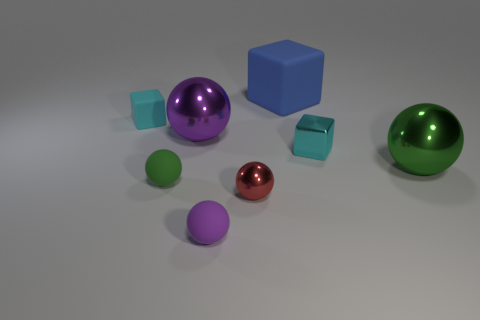How big is the cyan metallic object?
Keep it short and to the point. Small. How many cylinders are red objects or cyan metal objects?
Keep it short and to the point. 0. The green thing that is made of the same material as the tiny red ball is what size?
Offer a terse response. Large. How many other metal blocks are the same color as the shiny block?
Ensure brevity in your answer.  0. There is a big purple shiny thing; are there any big shiny objects to the left of it?
Offer a very short reply. No. Do the green shiny thing and the tiny rubber thing left of the tiny green ball have the same shape?
Provide a succinct answer. No. How many objects are green spheres left of the large green metal thing or tiny metal spheres?
Give a very brief answer. 2. Is there anything else that is the same material as the tiny purple ball?
Provide a succinct answer. Yes. How many small matte things are in front of the large purple metal object and on the left side of the purple metal object?
Ensure brevity in your answer.  1. What number of things are small spheres to the left of the tiny purple object or objects that are in front of the cyan matte thing?
Make the answer very short. 6. 